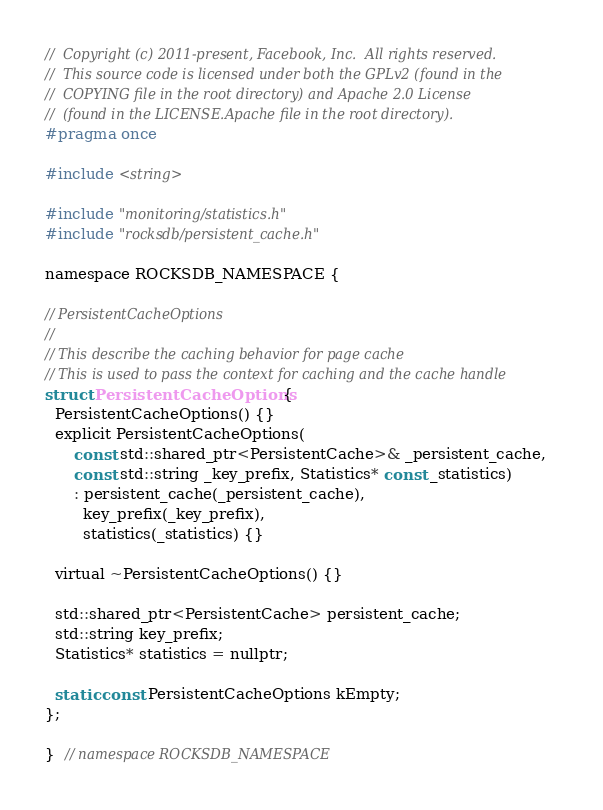Convert code to text. <code><loc_0><loc_0><loc_500><loc_500><_C_>//  Copyright (c) 2011-present, Facebook, Inc.  All rights reserved.
//  This source code is licensed under both the GPLv2 (found in the
//  COPYING file in the root directory) and Apache 2.0 License
//  (found in the LICENSE.Apache file in the root directory).
#pragma once

#include <string>

#include "monitoring/statistics.h"
#include "rocksdb/persistent_cache.h"

namespace ROCKSDB_NAMESPACE {

// PersistentCacheOptions
//
// This describe the caching behavior for page cache
// This is used to pass the context for caching and the cache handle
struct PersistentCacheOptions {
  PersistentCacheOptions() {}
  explicit PersistentCacheOptions(
      const std::shared_ptr<PersistentCache>& _persistent_cache,
      const std::string _key_prefix, Statistics* const _statistics)
      : persistent_cache(_persistent_cache),
        key_prefix(_key_prefix),
        statistics(_statistics) {}

  virtual ~PersistentCacheOptions() {}

  std::shared_ptr<PersistentCache> persistent_cache;
  std::string key_prefix;
  Statistics* statistics = nullptr;

  static const PersistentCacheOptions kEmpty;
};

}  // namespace ROCKSDB_NAMESPACE
</code> 